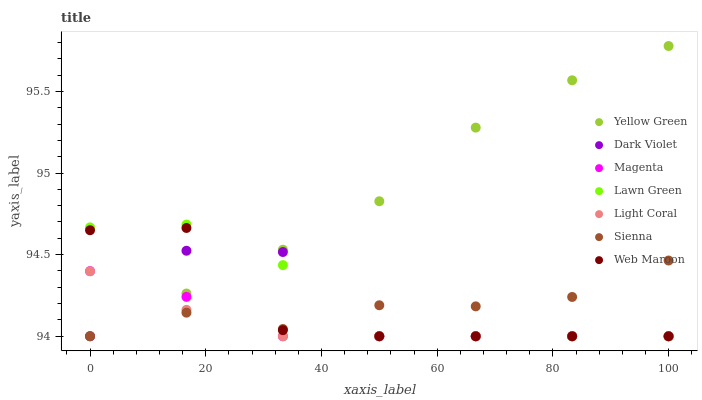Does Light Coral have the minimum area under the curve?
Answer yes or no. Yes. Does Yellow Green have the maximum area under the curve?
Answer yes or no. Yes. Does Web Maroon have the minimum area under the curve?
Answer yes or no. No. Does Web Maroon have the maximum area under the curve?
Answer yes or no. No. Is Light Coral the smoothest?
Answer yes or no. Yes. Is Dark Violet the roughest?
Answer yes or no. Yes. Is Yellow Green the smoothest?
Answer yes or no. No. Is Yellow Green the roughest?
Answer yes or no. No. Does Lawn Green have the lowest value?
Answer yes or no. Yes. Does Yellow Green have the highest value?
Answer yes or no. Yes. Does Web Maroon have the highest value?
Answer yes or no. No. Does Dark Violet intersect Web Maroon?
Answer yes or no. Yes. Is Dark Violet less than Web Maroon?
Answer yes or no. No. Is Dark Violet greater than Web Maroon?
Answer yes or no. No. 